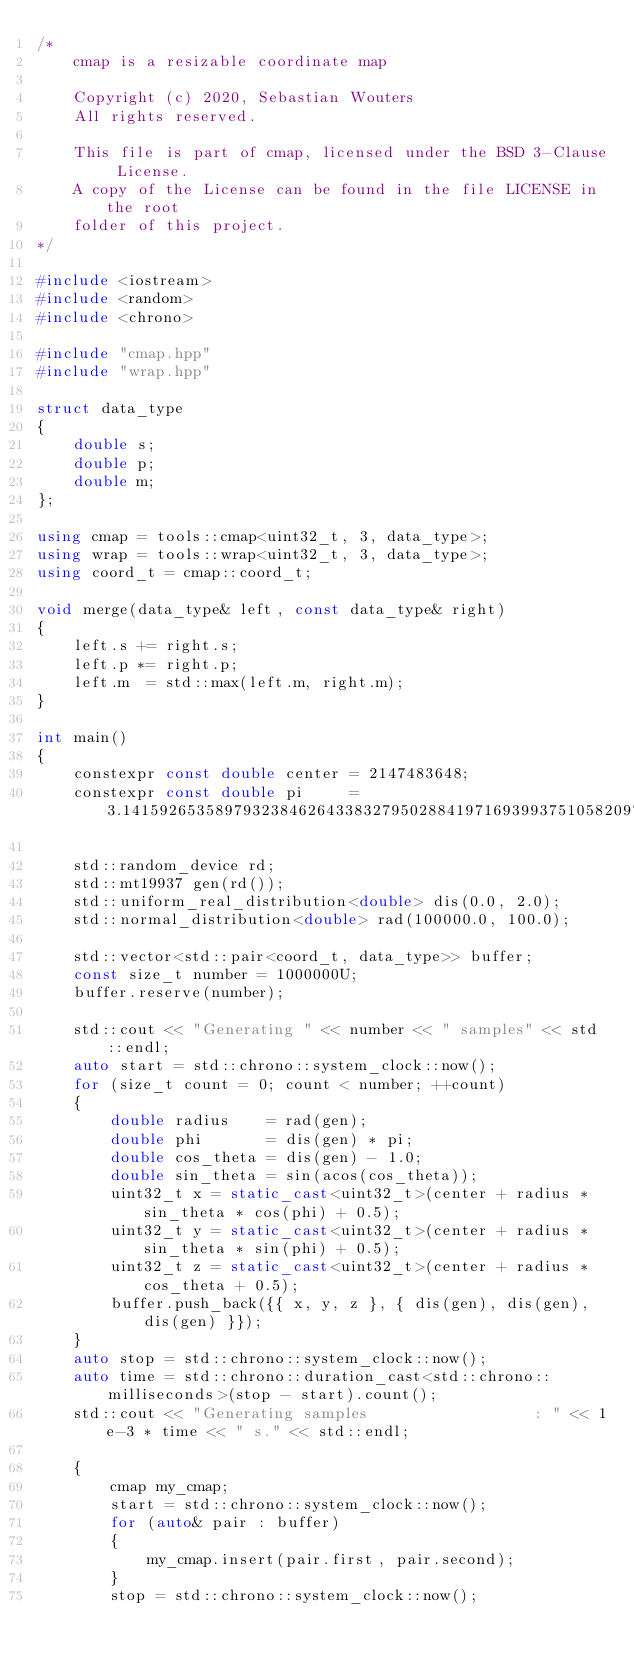Convert code to text. <code><loc_0><loc_0><loc_500><loc_500><_C++_>/*
    cmap is a resizable coordinate map

    Copyright (c) 2020, Sebastian Wouters
    All rights reserved.

    This file is part of cmap, licensed under the BSD 3-Clause License.
    A copy of the License can be found in the file LICENSE in the root
    folder of this project.
*/

#include <iostream>
#include <random>
#include <chrono>

#include "cmap.hpp"
#include "wrap.hpp"

struct data_type
{
    double s;
    double p;
    double m;
};

using cmap = tools::cmap<uint32_t, 3, data_type>;
using wrap = tools::wrap<uint32_t, 3, data_type>;
using coord_t = cmap::coord_t;

void merge(data_type& left, const data_type& right)
{
    left.s += right.s;
    left.p *= right.p;
    left.m  = std::max(left.m, right.m);
}

int main()
{
    constexpr const double center = 2147483648;
    constexpr const double pi     = 3.1415926535897932384626433832795028841971693993751058209749445923078164062862089986280348253421170679;

    std::random_device rd;
    std::mt19937 gen(rd());
    std::uniform_real_distribution<double> dis(0.0, 2.0);
    std::normal_distribution<double> rad(100000.0, 100.0);

    std::vector<std::pair<coord_t, data_type>> buffer;
    const size_t number = 1000000U;
    buffer.reserve(number);

    std::cout << "Generating " << number << " samples" << std::endl;
    auto start = std::chrono::system_clock::now();
    for (size_t count = 0; count < number; ++count)
    {
        double radius    = rad(gen);
        double phi       = dis(gen) * pi;
        double cos_theta = dis(gen) - 1.0;
        double sin_theta = sin(acos(cos_theta));
        uint32_t x = static_cast<uint32_t>(center + radius * sin_theta * cos(phi) + 0.5);
        uint32_t y = static_cast<uint32_t>(center + radius * sin_theta * sin(phi) + 0.5);
        uint32_t z = static_cast<uint32_t>(center + radius * cos_theta + 0.5);
        buffer.push_back({{ x, y, z }, { dis(gen), dis(gen), dis(gen) }});
    }
    auto stop = std::chrono::system_clock::now();
    auto time = std::chrono::duration_cast<std::chrono::milliseconds>(stop - start).count();
    std::cout << "Generating samples                  : " << 1e-3 * time << " s." << std::endl;

    {
        cmap my_cmap;
        start = std::chrono::system_clock::now();
        for (auto& pair : buffer)
        {
            my_cmap.insert(pair.first, pair.second);
        }
        stop = std::chrono::system_clock::now();</code> 